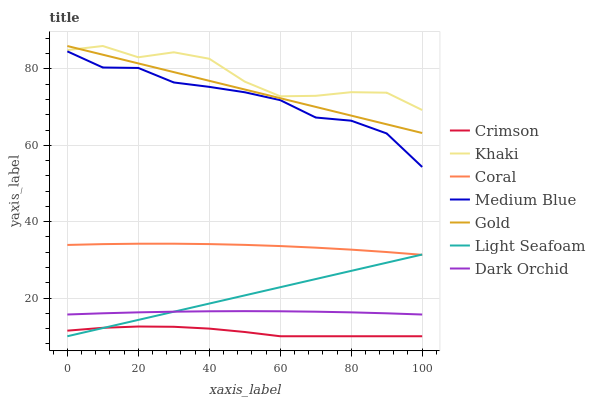Does Crimson have the minimum area under the curve?
Answer yes or no. Yes. Does Khaki have the maximum area under the curve?
Answer yes or no. Yes. Does Gold have the minimum area under the curve?
Answer yes or no. No. Does Gold have the maximum area under the curve?
Answer yes or no. No. Is Light Seafoam the smoothest?
Answer yes or no. Yes. Is Khaki the roughest?
Answer yes or no. Yes. Is Gold the smoothest?
Answer yes or no. No. Is Gold the roughest?
Answer yes or no. No. Does Crimson have the lowest value?
Answer yes or no. Yes. Does Gold have the lowest value?
Answer yes or no. No. Does Gold have the highest value?
Answer yes or no. Yes. Does Coral have the highest value?
Answer yes or no. No. Is Crimson less than Khaki?
Answer yes or no. Yes. Is Dark Orchid greater than Crimson?
Answer yes or no. Yes. Does Dark Orchid intersect Light Seafoam?
Answer yes or no. Yes. Is Dark Orchid less than Light Seafoam?
Answer yes or no. No. Is Dark Orchid greater than Light Seafoam?
Answer yes or no. No. Does Crimson intersect Khaki?
Answer yes or no. No. 